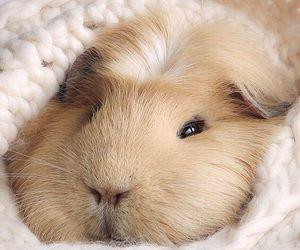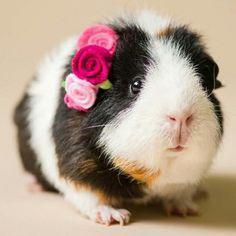The first image is the image on the left, the second image is the image on the right. Assess this claim about the two images: "There is at least one Guinea pig with an object in it's mouth.". Correct or not? Answer yes or no. No. The first image is the image on the left, the second image is the image on the right. For the images shown, is this caption "Each image contains exactly one guinea pig figure, and one image shows a guinea pig on a plush white textured fabric." true? Answer yes or no. Yes. 